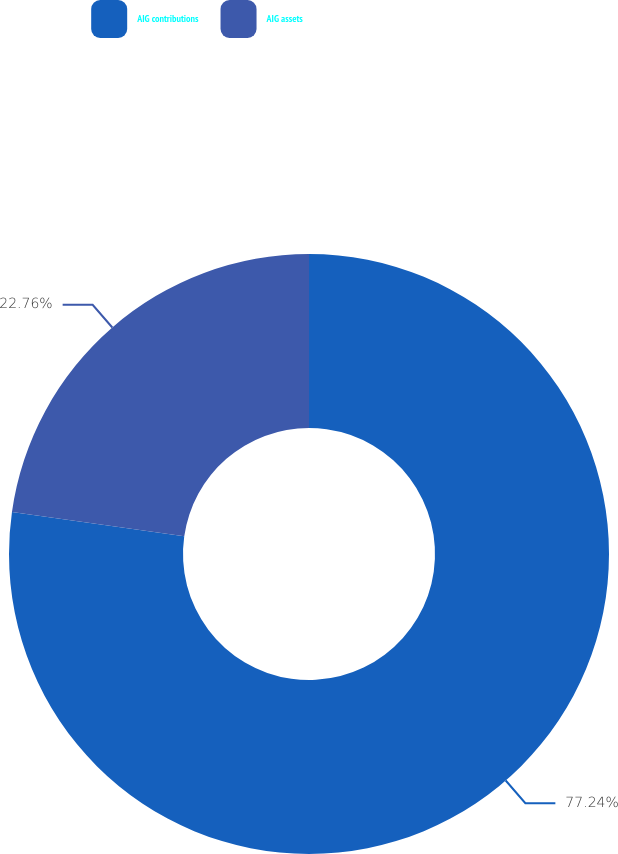<chart> <loc_0><loc_0><loc_500><loc_500><pie_chart><fcel>AIG contributions<fcel>AIG assets<nl><fcel>77.24%<fcel>22.76%<nl></chart> 